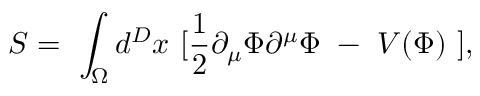<formula> <loc_0><loc_0><loc_500><loc_500>S = \int _ { \Omega } d ^ { D } x [ \frac { 1 } { 2 } \partial _ { \mu } \Phi \partial ^ { \mu } \Phi - V ( \Phi ) ] ,</formula> 